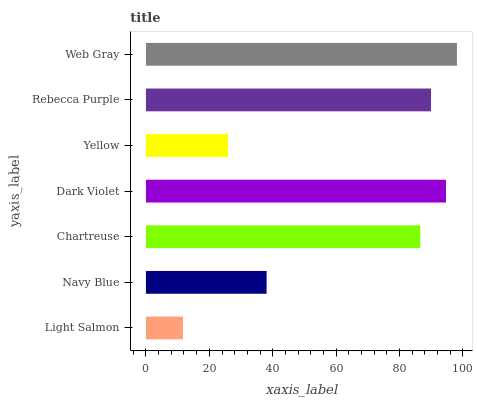Is Light Salmon the minimum?
Answer yes or no. Yes. Is Web Gray the maximum?
Answer yes or no. Yes. Is Navy Blue the minimum?
Answer yes or no. No. Is Navy Blue the maximum?
Answer yes or no. No. Is Navy Blue greater than Light Salmon?
Answer yes or no. Yes. Is Light Salmon less than Navy Blue?
Answer yes or no. Yes. Is Light Salmon greater than Navy Blue?
Answer yes or no. No. Is Navy Blue less than Light Salmon?
Answer yes or no. No. Is Chartreuse the high median?
Answer yes or no. Yes. Is Chartreuse the low median?
Answer yes or no. Yes. Is Light Salmon the high median?
Answer yes or no. No. Is Light Salmon the low median?
Answer yes or no. No. 